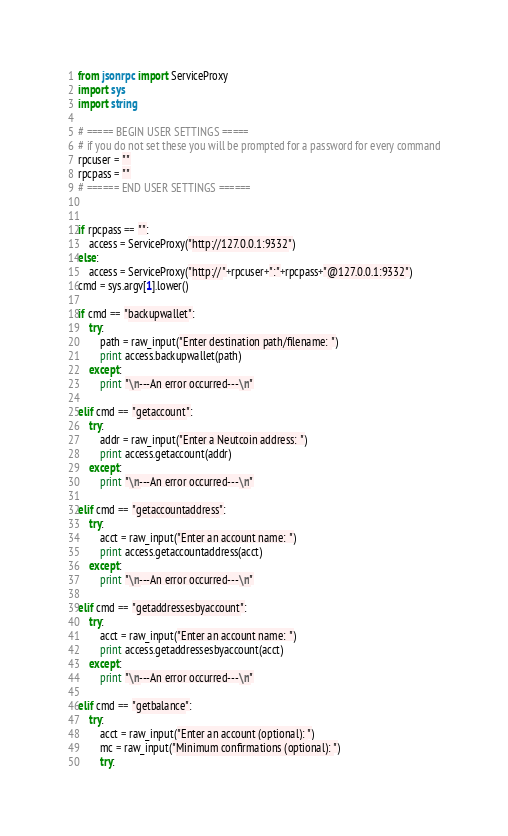<code> <loc_0><loc_0><loc_500><loc_500><_Python_>from jsonrpc import ServiceProxy
import sys
import string

# ===== BEGIN USER SETTINGS =====
# if you do not set these you will be prompted for a password for every command
rpcuser = ""
rpcpass = ""
# ====== END USER SETTINGS ======


if rpcpass == "":
	access = ServiceProxy("http://127.0.0.1:9332")
else:
	access = ServiceProxy("http://"+rpcuser+":"+rpcpass+"@127.0.0.1:9332")
cmd = sys.argv[1].lower()

if cmd == "backupwallet":
	try:
		path = raw_input("Enter destination path/filename: ")
		print access.backupwallet(path)
	except:
		print "\n---An error occurred---\n"

elif cmd == "getaccount":
	try:
		addr = raw_input("Enter a Neutcoin address: ")
		print access.getaccount(addr)
	except:
		print "\n---An error occurred---\n"

elif cmd == "getaccountaddress":
	try:
		acct = raw_input("Enter an account name: ")
		print access.getaccountaddress(acct)
	except:
		print "\n---An error occurred---\n"

elif cmd == "getaddressesbyaccount":
	try:
		acct = raw_input("Enter an account name: ")
		print access.getaddressesbyaccount(acct)
	except:
		print "\n---An error occurred---\n"

elif cmd == "getbalance":
	try:
		acct = raw_input("Enter an account (optional): ")
		mc = raw_input("Minimum confirmations (optional): ")
		try:</code> 